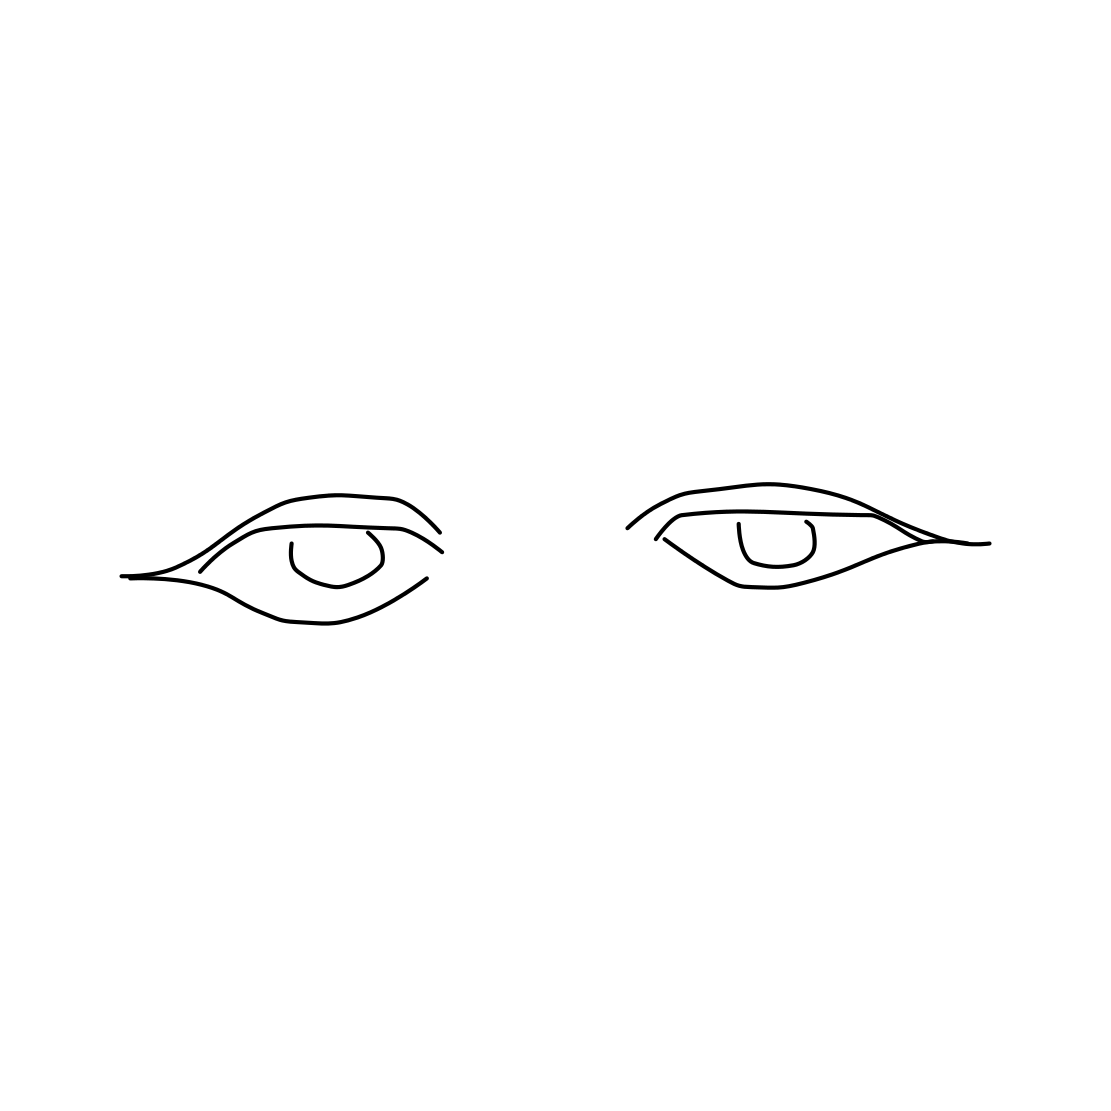Could you tell me the artistic techniques used in drawing these eyes? Sure, the artist used clean, confident lines with minimal shading to create these eyes, which is common in line art. The technique emphasizes form and structure, focusing on the outline and essential features without the addition of texture or depth, resulting in a striking, stylized appearance. 